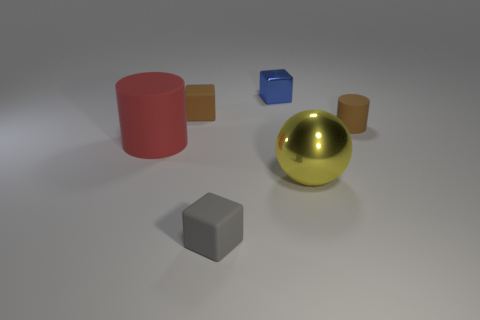If the objects in the image were to represent a family, what roles might they play based on their sizes and positions? The large red cylinder could be seen as a protective parent figure, the golden sphere as a radiant central figure perhaps a child, the grey cube as a solid, steady sibling, and the smaller cylinders and cube might represent younger siblings or pets due to their smaller sizes and scattered positions. 